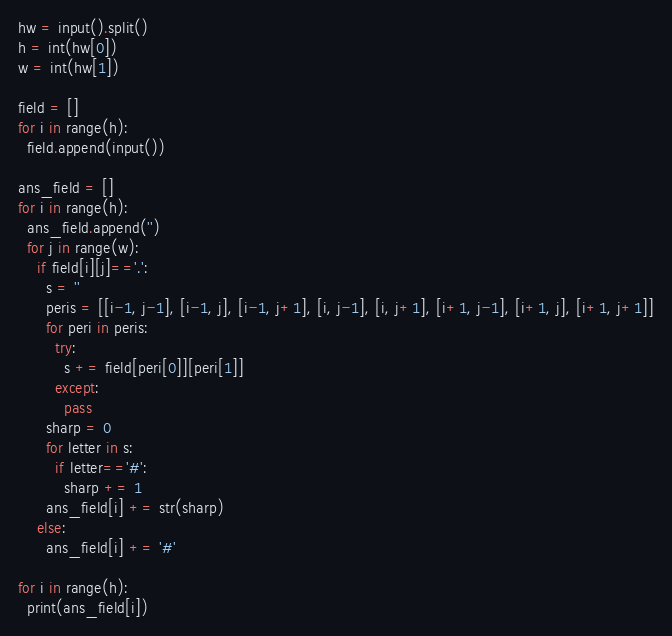Convert code to text. <code><loc_0><loc_0><loc_500><loc_500><_Python_>hw = input().split()
h = int(hw[0])
w = int(hw[1])

field = []
for i in range(h):
  field.append(input())

ans_field = []
for i in range(h):
  ans_field.append('')
  for j in range(w):
    if field[i][j]=='.':
      s = ''
      peris = [[i-1, j-1], [i-1, j], [i-1, j+1], [i, j-1], [i, j+1], [i+1, j-1], [i+1, j], [i+1, j+1]]
      for peri in peris:
        try:
          s += field[peri[0]][peri[1]]
        except:
          pass
      sharp = 0
      for letter in s:
        if letter=='#':
          sharp += 1
      ans_field[i] += str(sharp)
    else:
      ans_field[i] += '#'

for i in range(h):
  print(ans_field[i])
</code> 